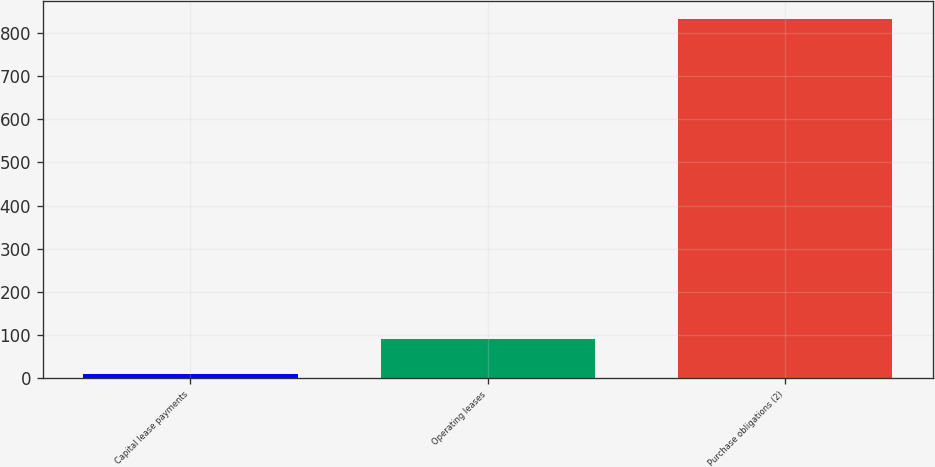Convert chart. <chart><loc_0><loc_0><loc_500><loc_500><bar_chart><fcel>Capital lease payments<fcel>Operating leases<fcel>Purchase obligations (2)<nl><fcel>9<fcel>91.3<fcel>832<nl></chart> 